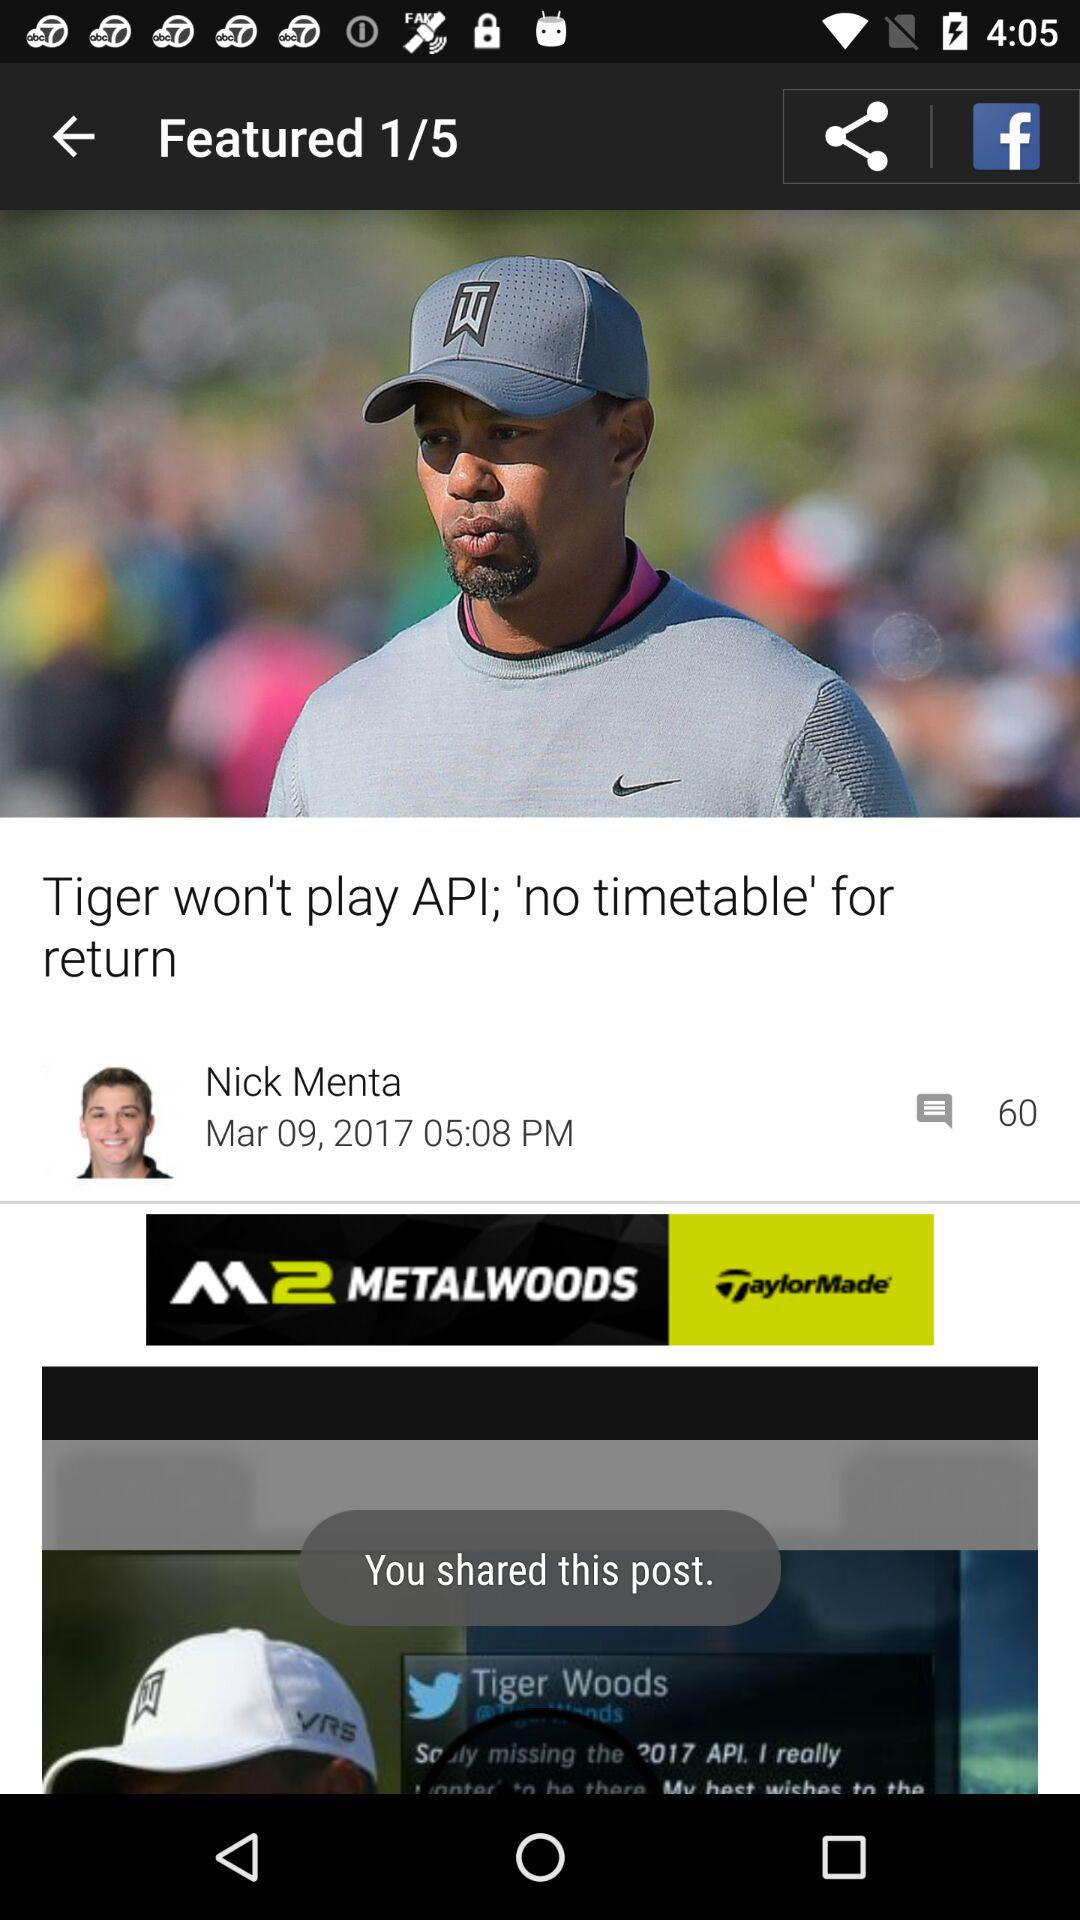What is the posted time of the post? The posted time is 5:08 PM. 